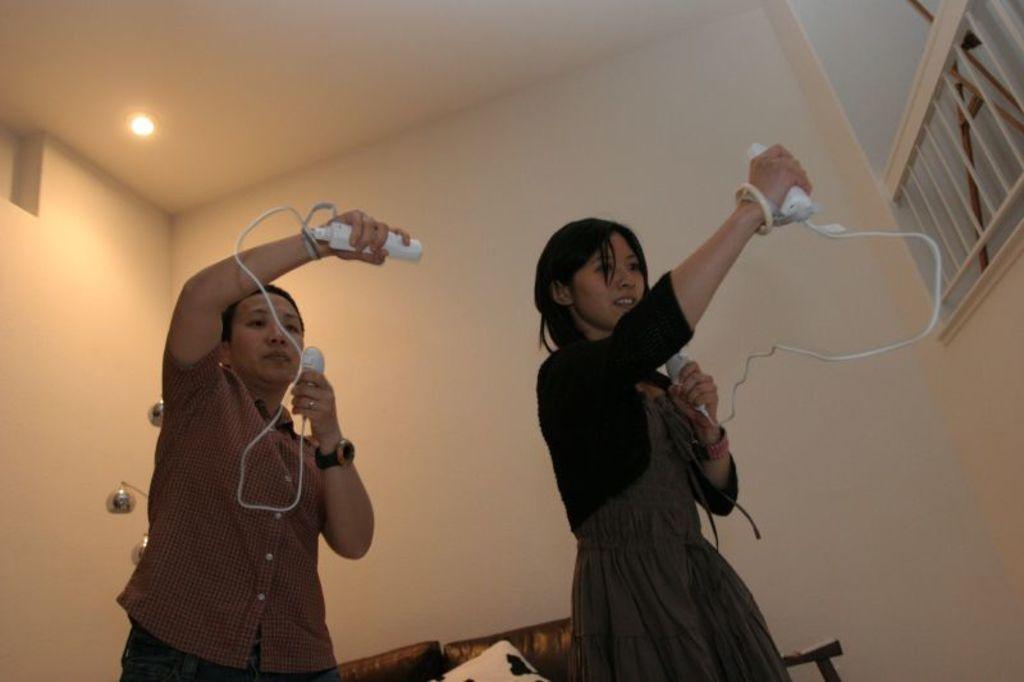Describe this image in one or two sentences. This is an image clicked inside the room. In this image I can see two persons holding some device in their hands. One is man and one is woman. In the background I can see a wall. On the top of the image I can see a light. In the background I can see two chairs. 